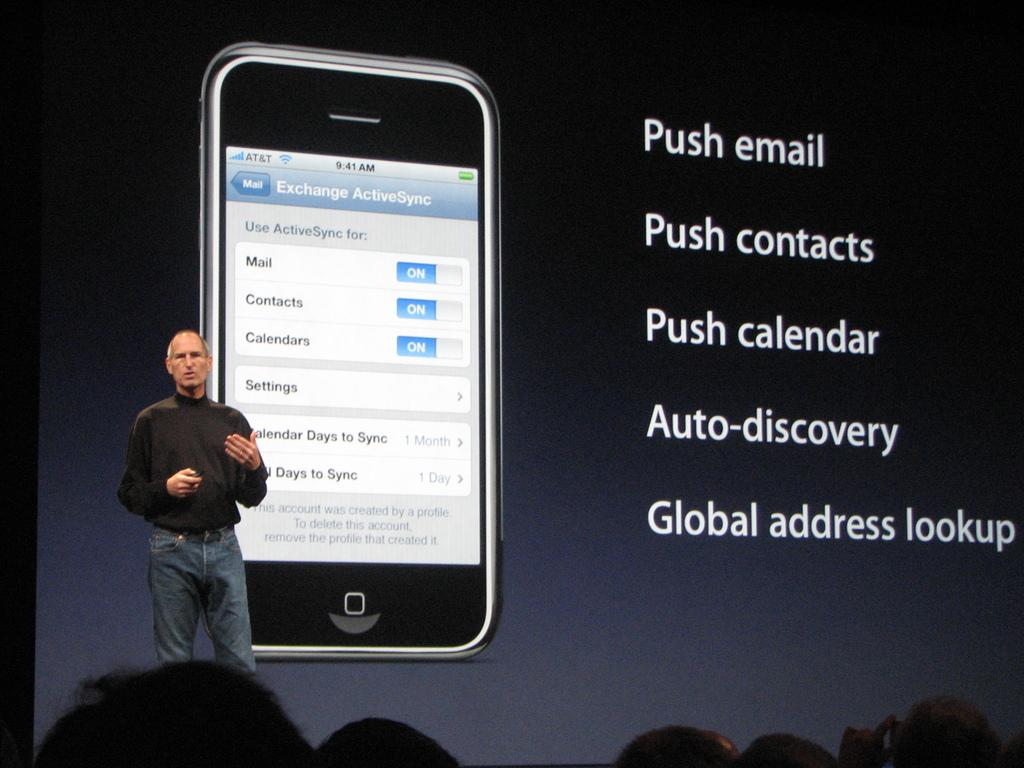<image>
Summarize the visual content of the image. A cellphone with a mail app setting page displayed titled Exchange ActiveSync. 